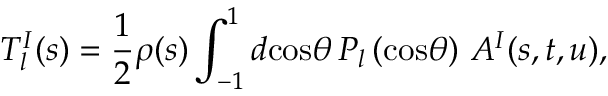Convert formula to latex. <formula><loc_0><loc_0><loc_500><loc_500>T _ { l } ^ { I } ( s ) = \frac { 1 } { 2 } \rho ( s ) \int _ { - 1 } ^ { 1 } d \cos \theta \, P _ { l } \left ( \cos \theta \right ) \, A ^ { I } ( s , t , u ) ,</formula> 